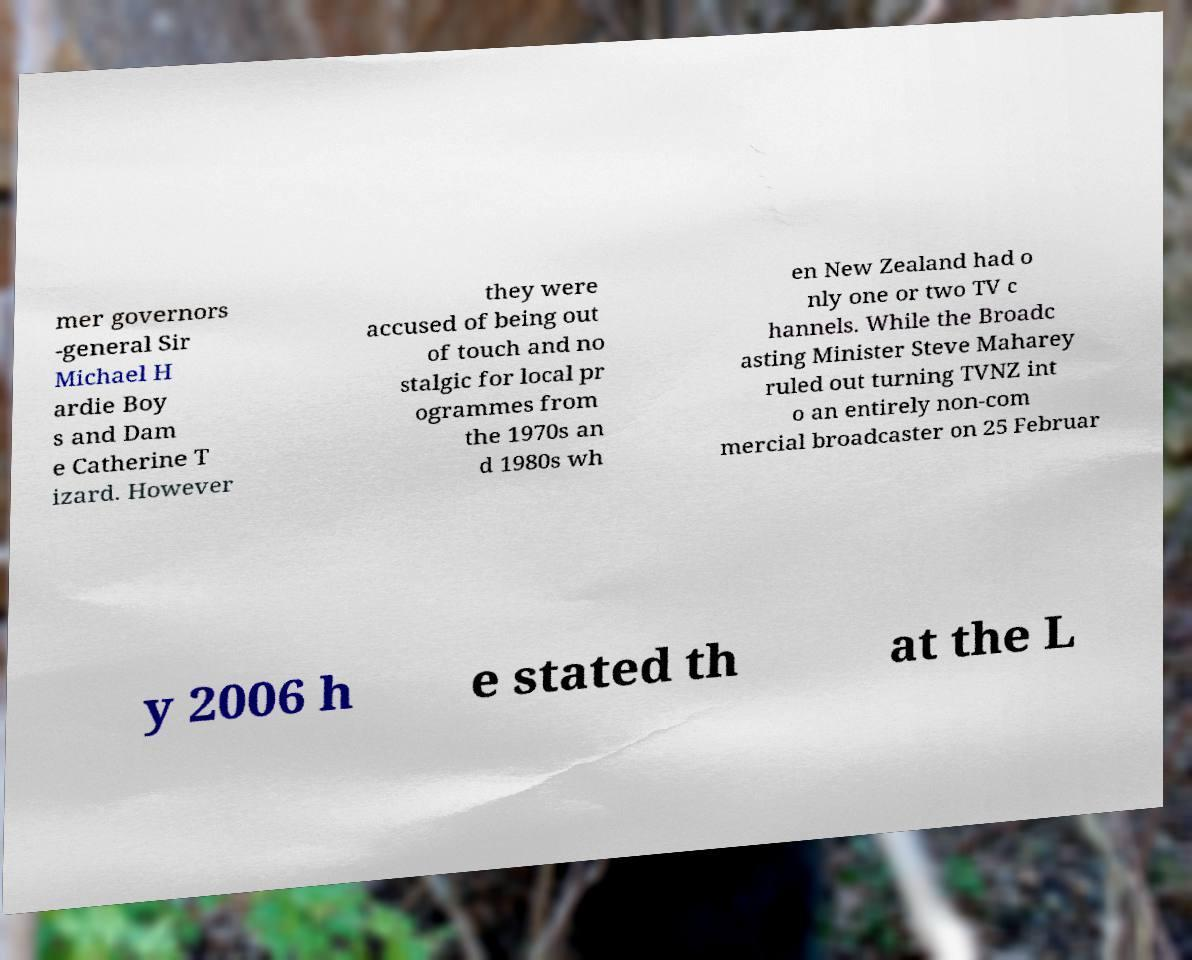What messages or text are displayed in this image? I need them in a readable, typed format. mer governors -general Sir Michael H ardie Boy s and Dam e Catherine T izard. However they were accused of being out of touch and no stalgic for local pr ogrammes from the 1970s an d 1980s wh en New Zealand had o nly one or two TV c hannels. While the Broadc asting Minister Steve Maharey ruled out turning TVNZ int o an entirely non-com mercial broadcaster on 25 Februar y 2006 h e stated th at the L 